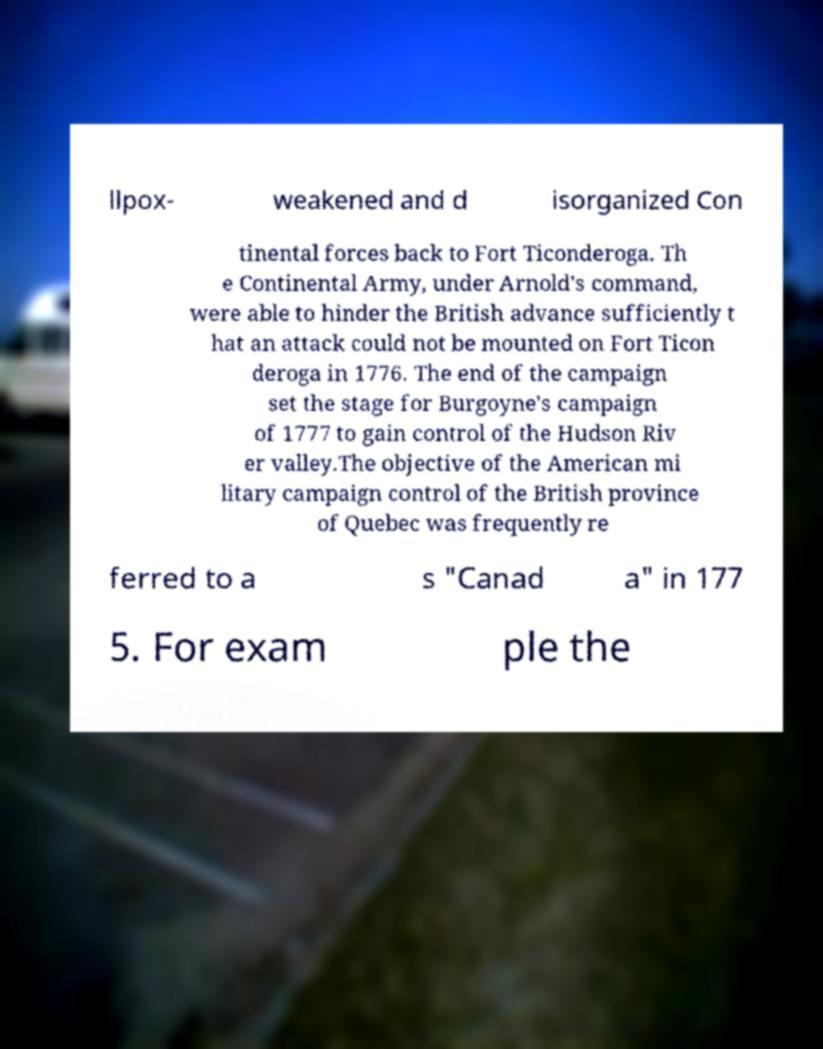What messages or text are displayed in this image? I need them in a readable, typed format. llpox- weakened and d isorganized Con tinental forces back to Fort Ticonderoga. Th e Continental Army, under Arnold's command, were able to hinder the British advance sufficiently t hat an attack could not be mounted on Fort Ticon deroga in 1776. The end of the campaign set the stage for Burgoyne's campaign of 1777 to gain control of the Hudson Riv er valley.The objective of the American mi litary campaign control of the British province of Quebec was frequently re ferred to a s "Canad a" in 177 5. For exam ple the 